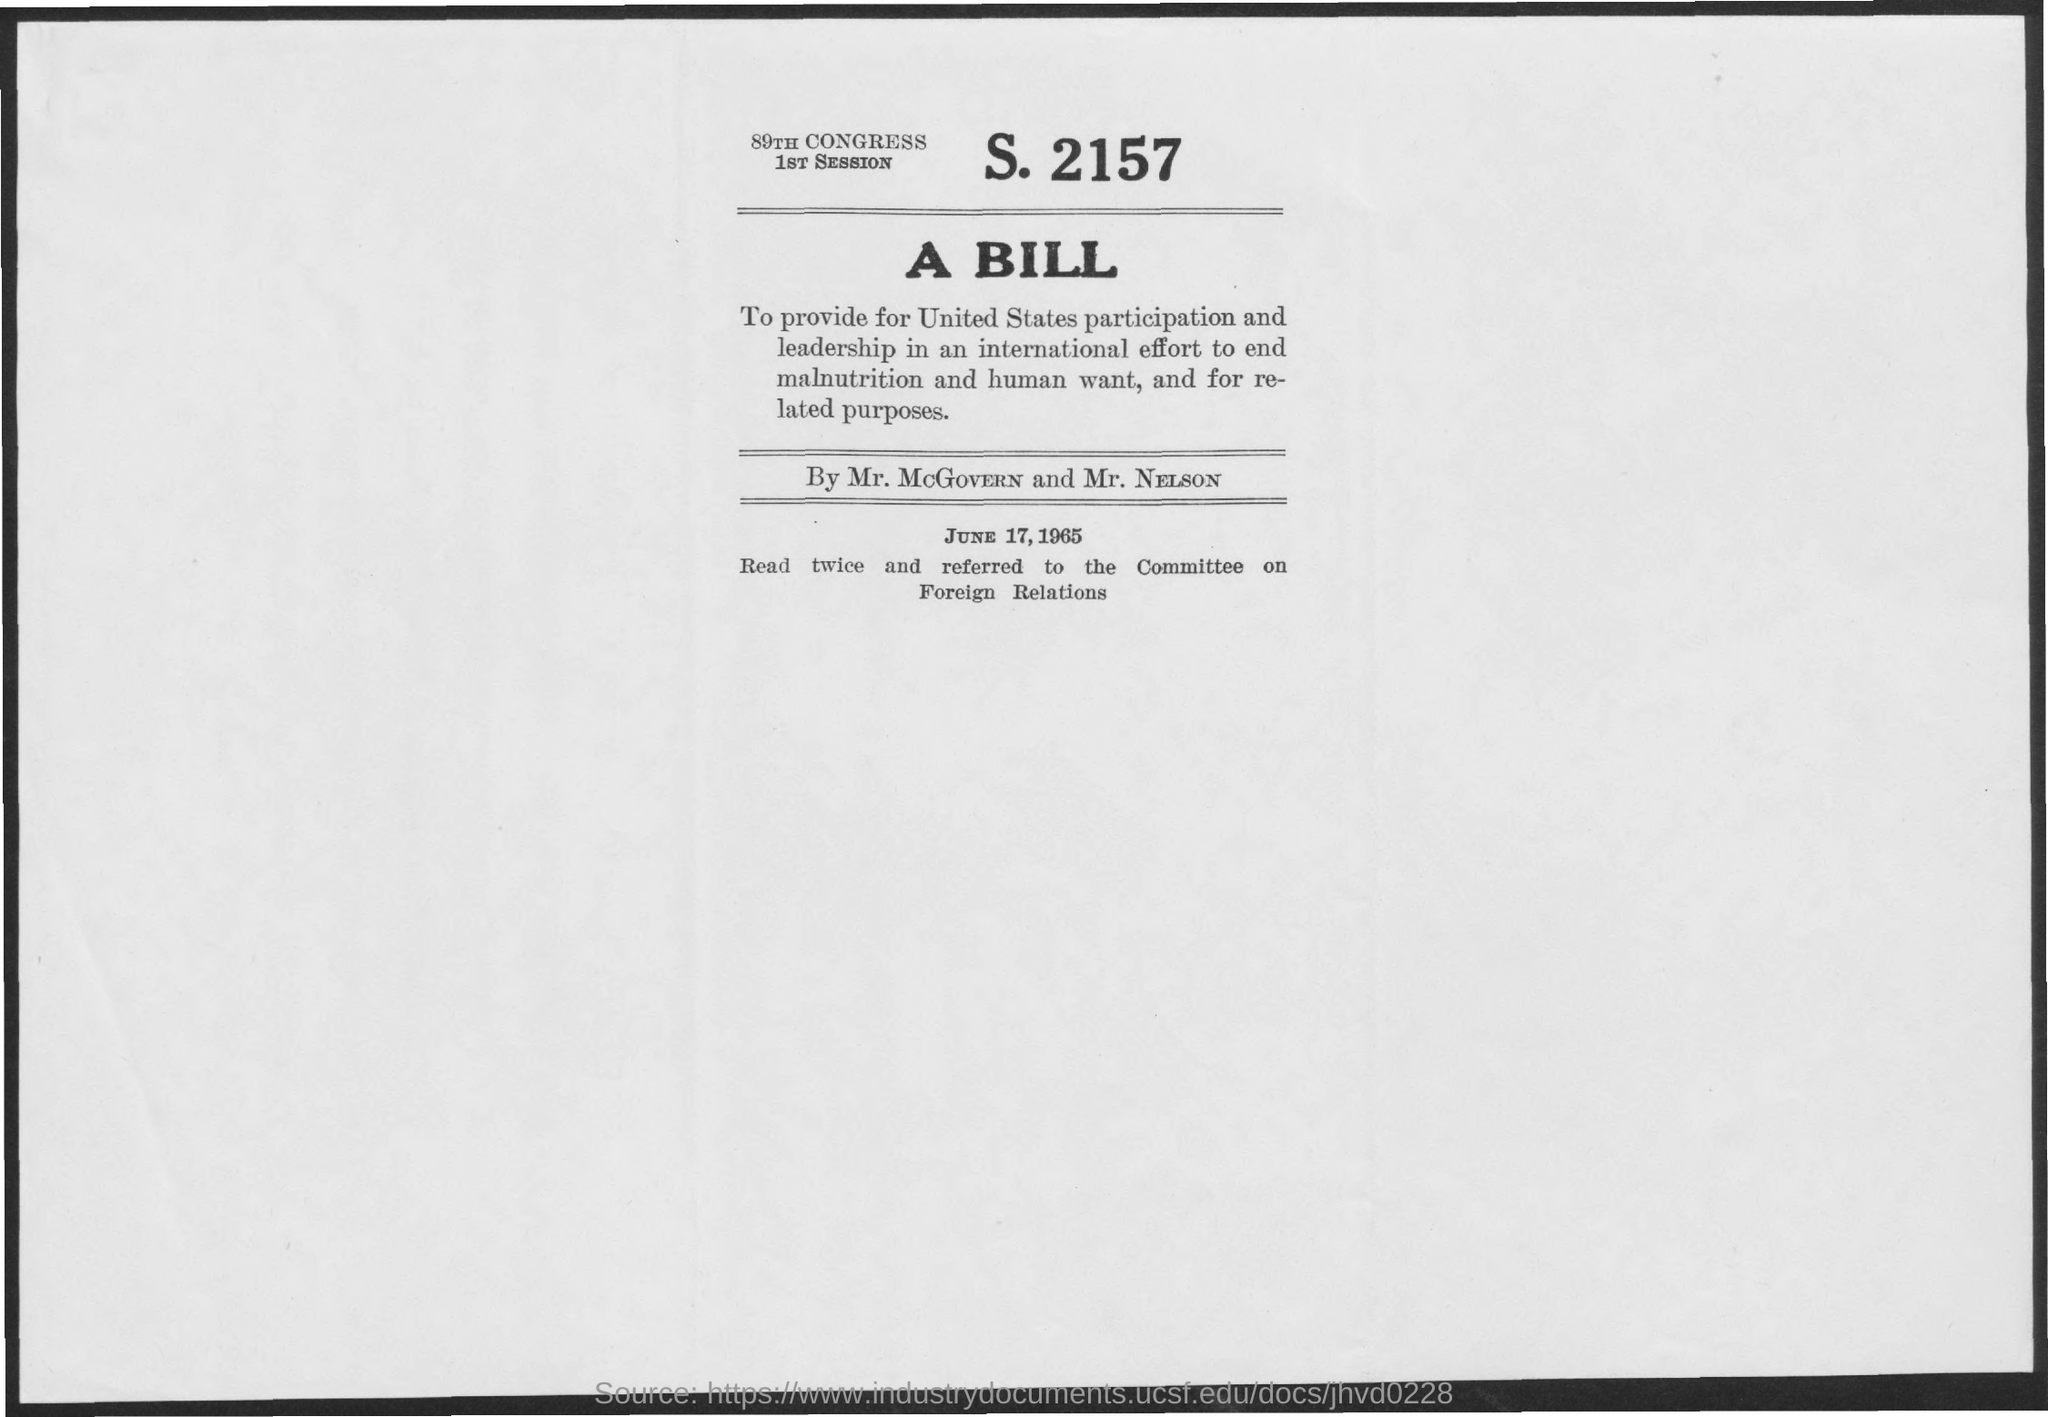Outline some significant characteristics in this image. The date mentioned in the document is June 17, 1965. 